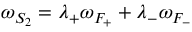Convert formula to latex. <formula><loc_0><loc_0><loc_500><loc_500>\omega _ { S _ { 2 } } = \lambda _ { + } \omega _ { F _ { + } } + \lambda _ { - } \omega _ { F _ { - } }</formula> 